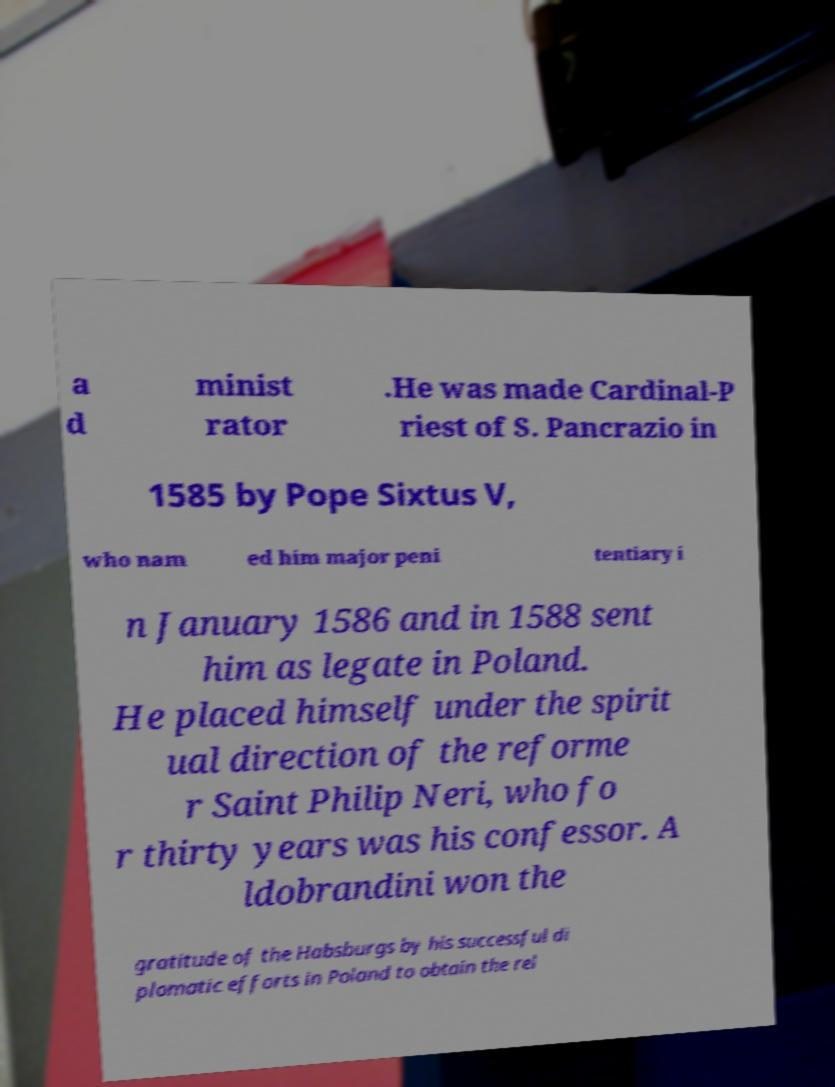Please identify and transcribe the text found in this image. a d minist rator .He was made Cardinal-P riest of S. Pancrazio in 1585 by Pope Sixtus V, who nam ed him major peni tentiary i n January 1586 and in 1588 sent him as legate in Poland. He placed himself under the spirit ual direction of the reforme r Saint Philip Neri, who fo r thirty years was his confessor. A ldobrandini won the gratitude of the Habsburgs by his successful di plomatic efforts in Poland to obtain the rel 